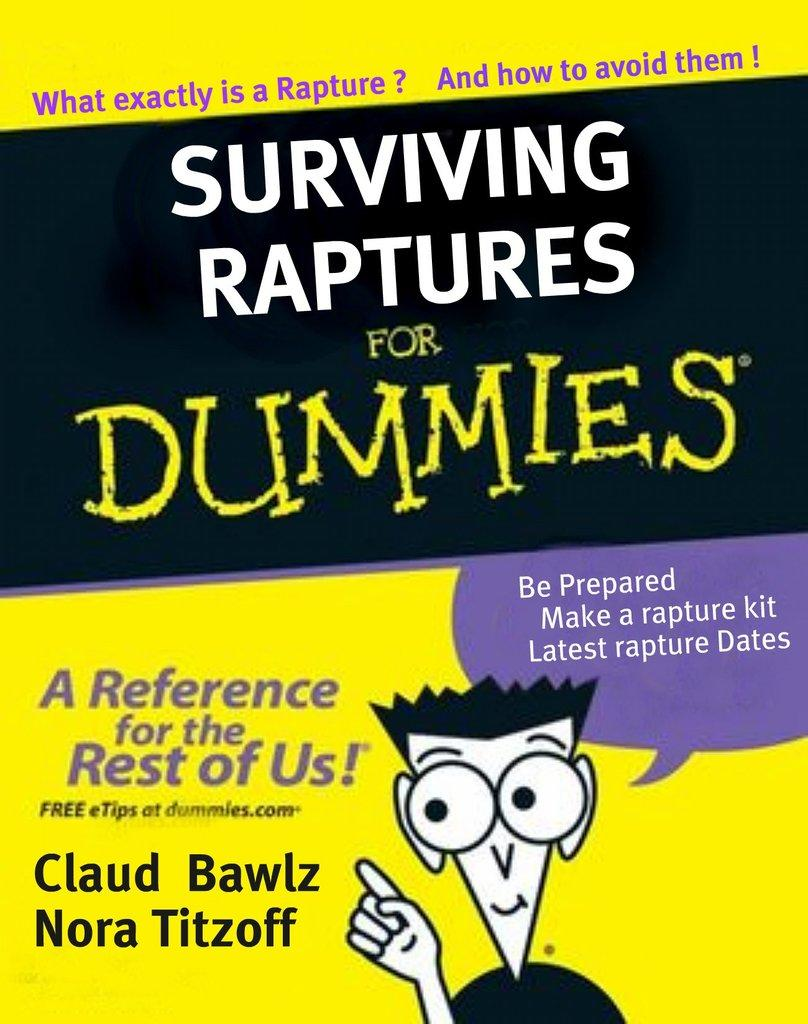<image>
Create a compact narrative representing the image presented. A paperback book titled Surviving Raptures for Dummies. 